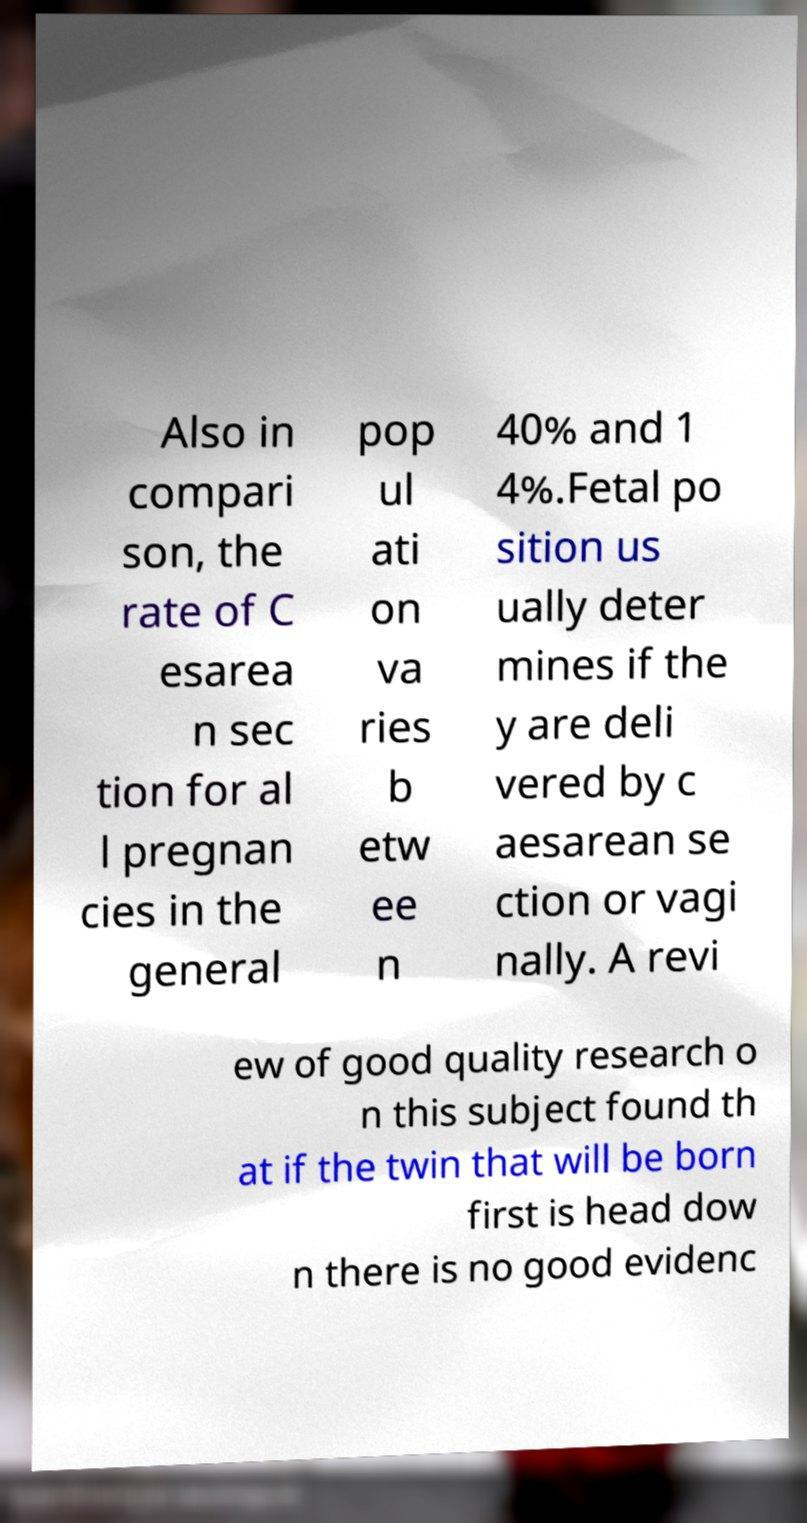Could you assist in decoding the text presented in this image and type it out clearly? Also in compari son, the rate of C esarea n sec tion for al l pregnan cies in the general pop ul ati on va ries b etw ee n 40% and 1 4%.Fetal po sition us ually deter mines if the y are deli vered by c aesarean se ction or vagi nally. A revi ew of good quality research o n this subject found th at if the twin that will be born first is head dow n there is no good evidenc 